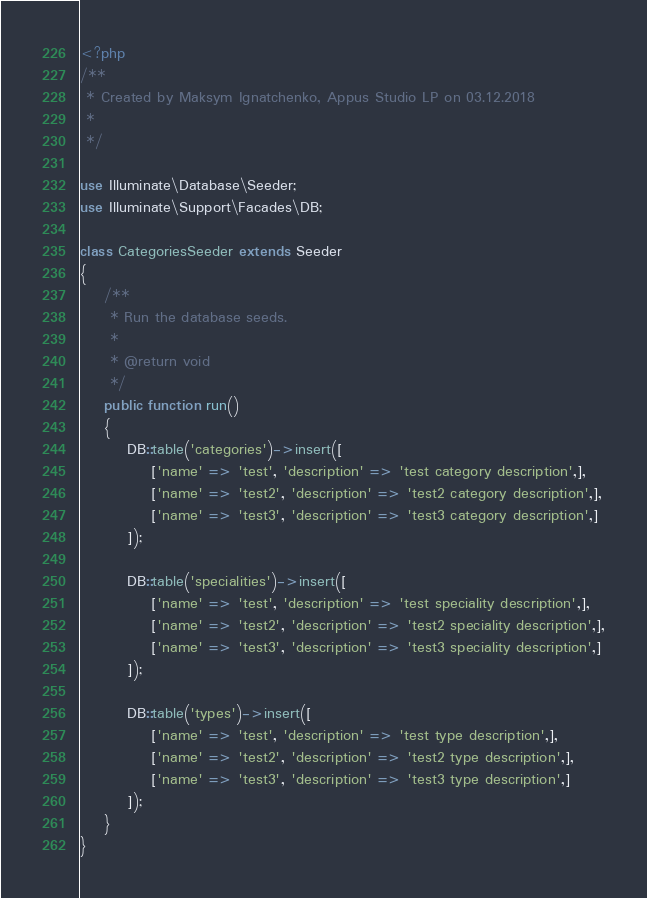<code> <loc_0><loc_0><loc_500><loc_500><_PHP_><?php
/**
 * Created by Maksym Ignatchenko, Appus Studio LP on 03.12.2018
 *
 */

use Illuminate\Database\Seeder;
use Illuminate\Support\Facades\DB;

class CategoriesSeeder extends Seeder
{
    /**
     * Run the database seeds.
     *
     * @return void
     */
    public function run()
    {
        DB::table('categories')->insert([
            ['name' => 'test', 'description' => 'test category description',],
            ['name' => 'test2', 'description' => 'test2 category description',],
            ['name' => 'test3', 'description' => 'test3 category description',]
        ]);

        DB::table('specialities')->insert([
            ['name' => 'test', 'description' => 'test speciality description',],
            ['name' => 'test2', 'description' => 'test2 speciality description',],
            ['name' => 'test3', 'description' => 'test3 speciality description',]
        ]);

        DB::table('types')->insert([
            ['name' => 'test', 'description' => 'test type description',],
            ['name' => 'test2', 'description' => 'test2 type description',],
            ['name' => 'test3', 'description' => 'test3 type description',]
        ]);
    }
}
</code> 